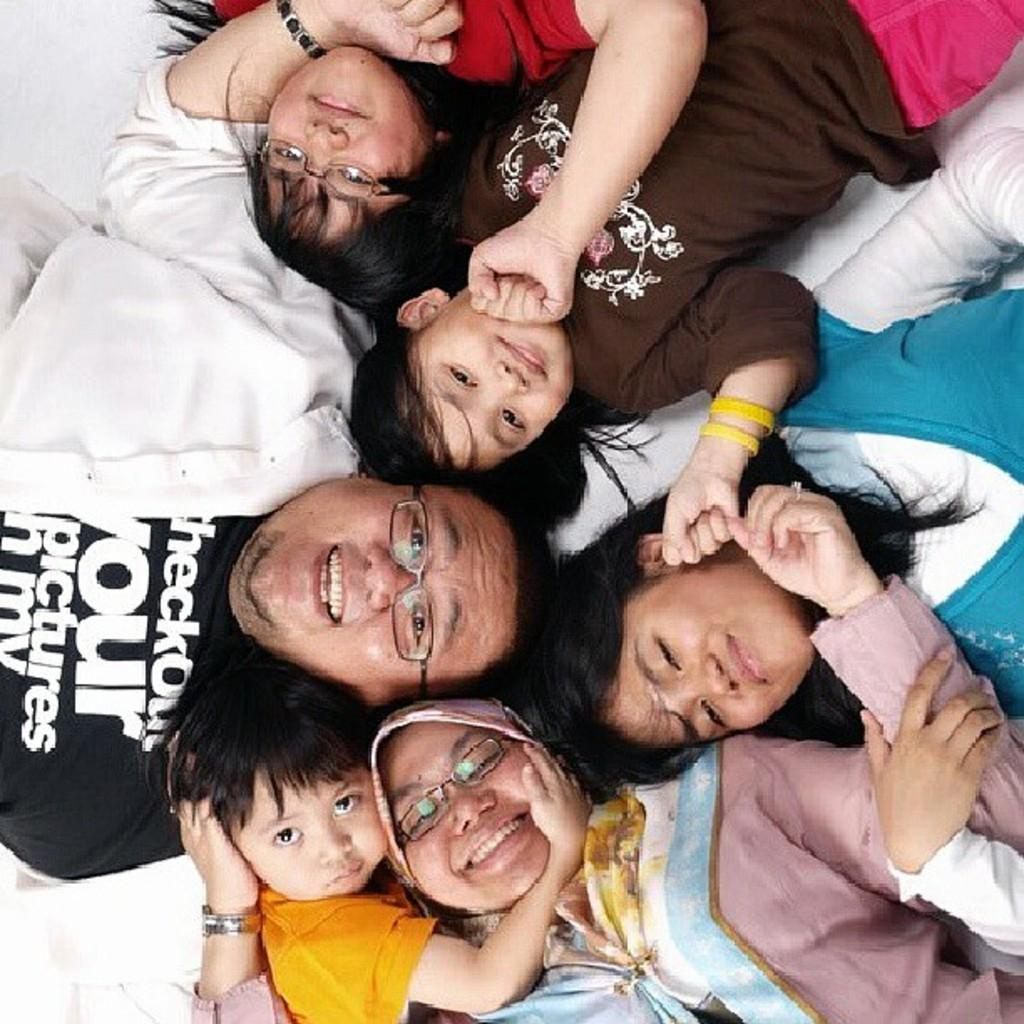How many people are in the image? There are persons in the image. What are the persons doing in the image? The persons are lying on the floor. What expression do the persons have in the image? The persons are smiling. What type of whip can be seen in the hands of the persons in the image? There is no whip present in the image; the persons are lying on the floor and smiling. What color is the yarn that the persons are using to knit in the image? There is no yarn or knitting activity present in the image; the persons are simply lying on the floor and smiling. 